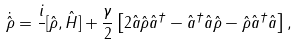<formula> <loc_0><loc_0><loc_500><loc_500>\dot { \hat { \rho } } = \frac { i } { } [ \hat { \rho } , \hat { H } ] + \frac { \gamma } { 2 } \left [ 2 \hat { a } \hat { \rho } \hat { a } ^ { \dag } - \hat { a } ^ { \dag } \hat { a } \hat { \rho } - \hat { \rho } \hat { a } ^ { \dag } \hat { a } \right ] ,</formula> 